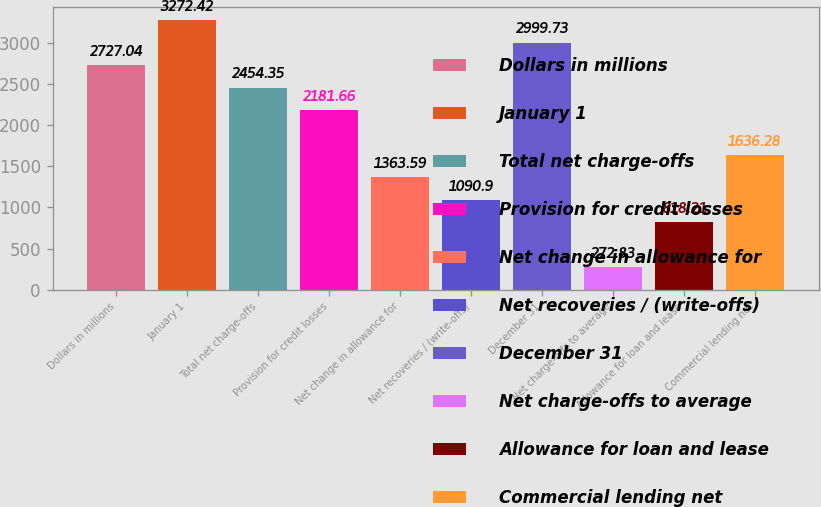Convert chart. <chart><loc_0><loc_0><loc_500><loc_500><bar_chart><fcel>Dollars in millions<fcel>January 1<fcel>Total net charge-offs<fcel>Provision for credit losses<fcel>Net change in allowance for<fcel>Net recoveries / (write-offs)<fcel>December 31<fcel>Net charge-offs to average<fcel>Allowance for loan and lease<fcel>Commercial lending net<nl><fcel>2727.04<fcel>3272.42<fcel>2454.35<fcel>2181.66<fcel>1363.59<fcel>1090.9<fcel>2999.73<fcel>272.83<fcel>818.21<fcel>1636.28<nl></chart> 